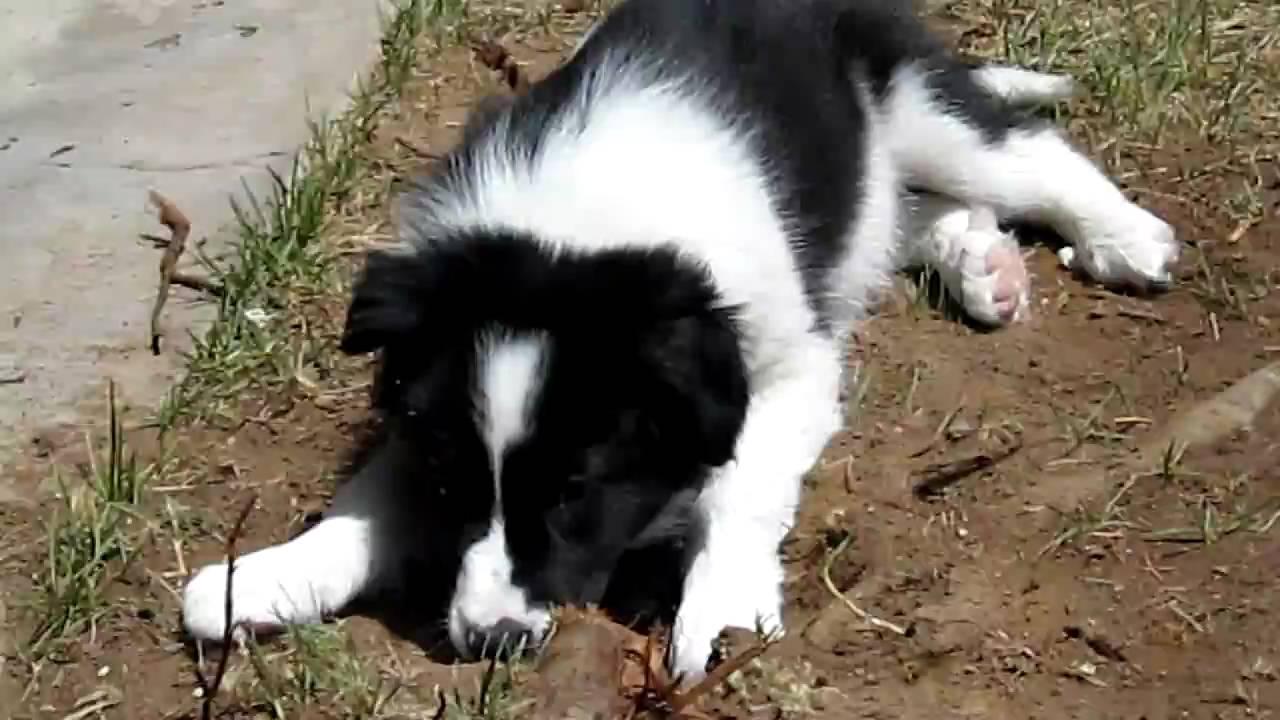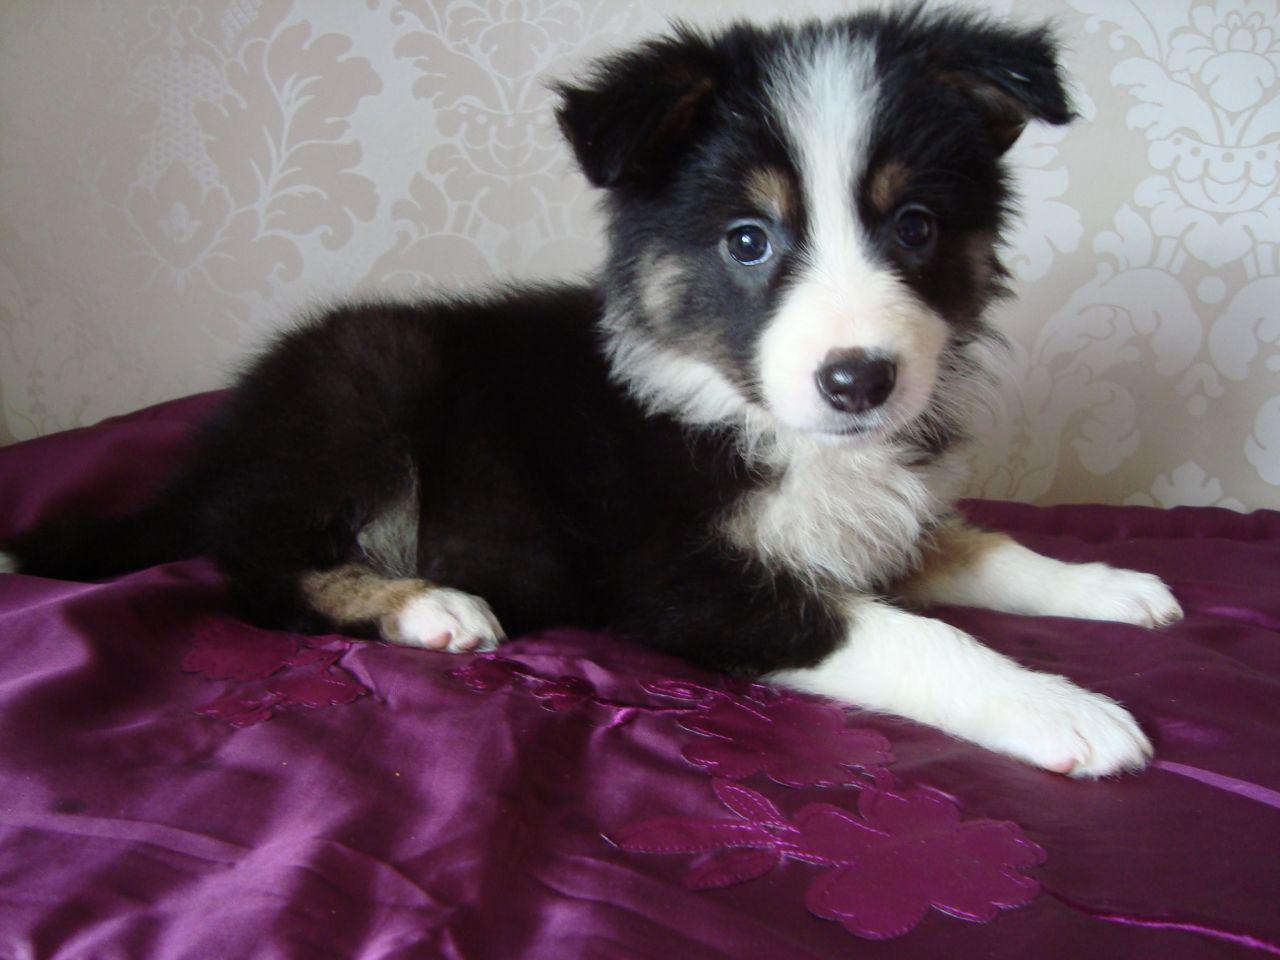The first image is the image on the left, the second image is the image on the right. Assess this claim about the two images: "One of the pups is on the sidewalk.". Correct or not? Answer yes or no. No. The first image is the image on the left, the second image is the image on the right. Evaluate the accuracy of this statement regarding the images: "All of the dogs are sitting.". Is it true? Answer yes or no. No. 